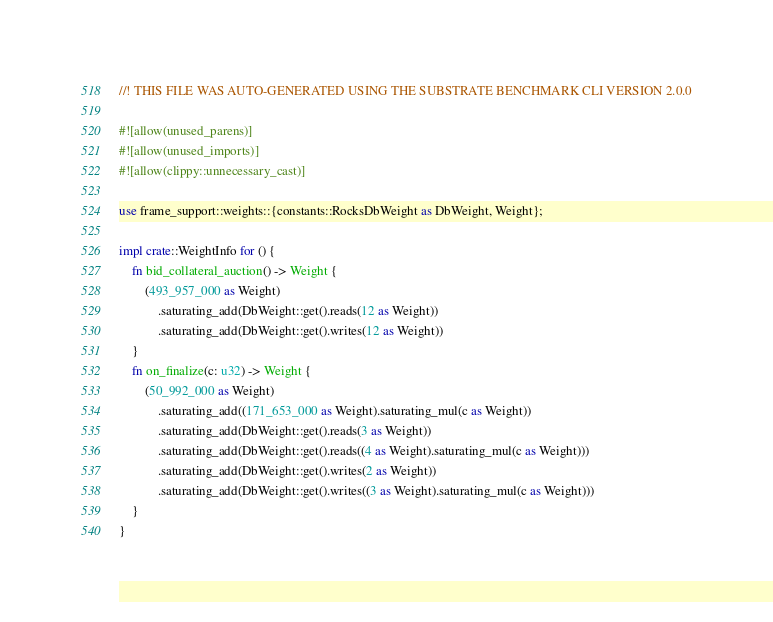Convert code to text. <code><loc_0><loc_0><loc_500><loc_500><_Rust_>//! THIS FILE WAS AUTO-GENERATED USING THE SUBSTRATE BENCHMARK CLI VERSION 2.0.0

#![allow(unused_parens)]
#![allow(unused_imports)]
#![allow(clippy::unnecessary_cast)]

use frame_support::weights::{constants::RocksDbWeight as DbWeight, Weight};

impl crate::WeightInfo for () {
	fn bid_collateral_auction() -> Weight {
		(493_957_000 as Weight)
			.saturating_add(DbWeight::get().reads(12 as Weight))
			.saturating_add(DbWeight::get().writes(12 as Weight))
	}
	fn on_finalize(c: u32) -> Weight {
		(50_992_000 as Weight)
			.saturating_add((171_653_000 as Weight).saturating_mul(c as Weight))
			.saturating_add(DbWeight::get().reads(3 as Weight))
			.saturating_add(DbWeight::get().reads((4 as Weight).saturating_mul(c as Weight)))
			.saturating_add(DbWeight::get().writes(2 as Weight))
			.saturating_add(DbWeight::get().writes((3 as Weight).saturating_mul(c as Weight)))
	}
}
</code> 